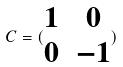Convert formula to latex. <formula><loc_0><loc_0><loc_500><loc_500>C = ( \begin{matrix} 1 & 0 \\ 0 & - 1 \end{matrix} )</formula> 